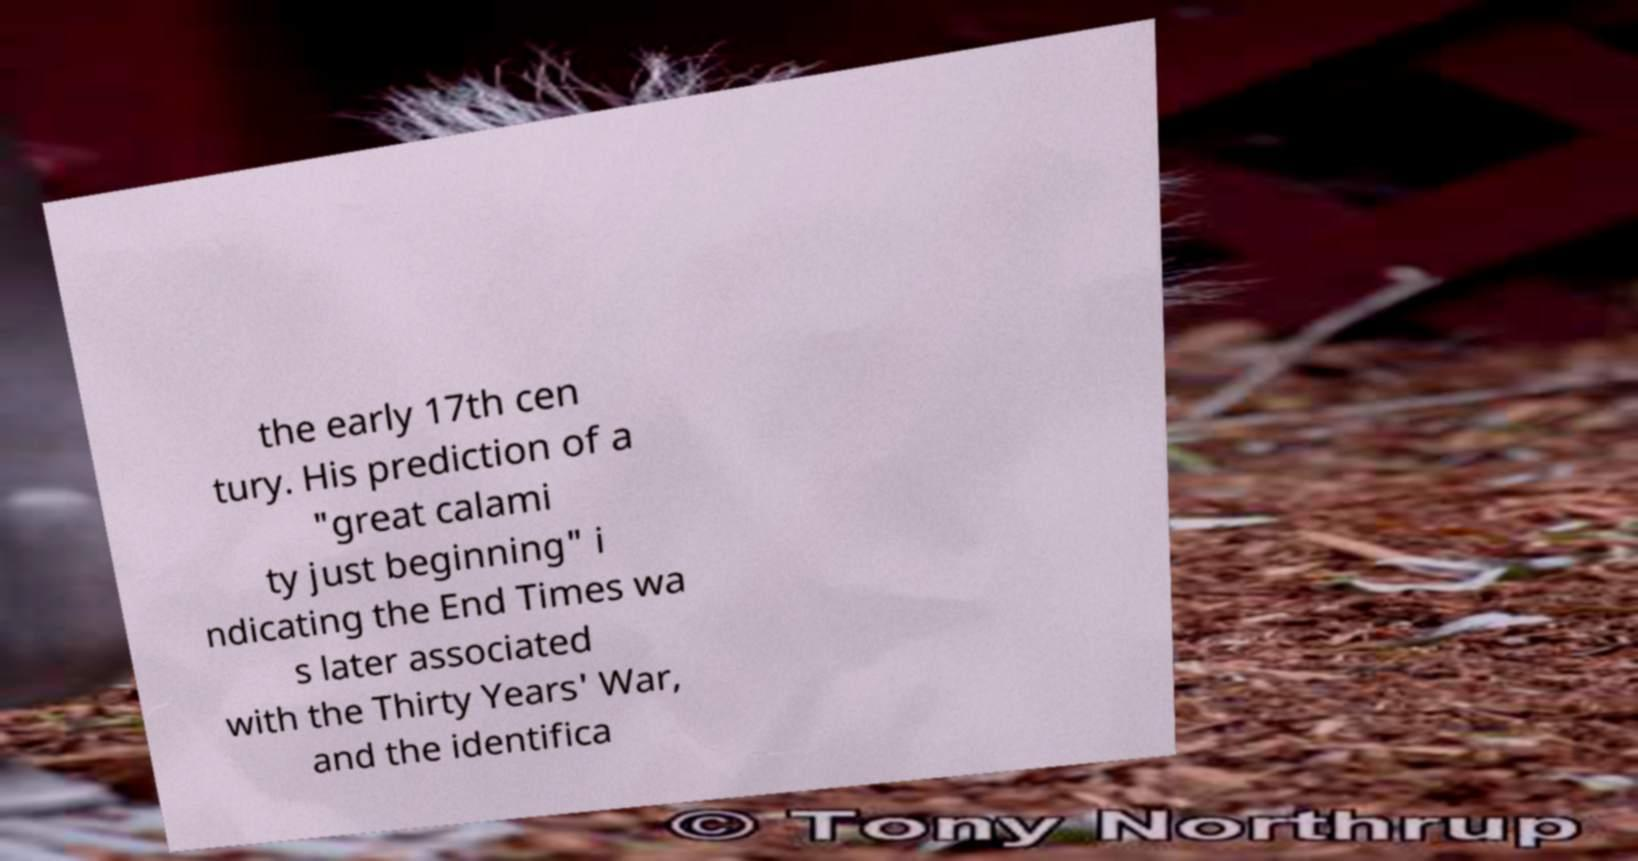What messages or text are displayed in this image? I need them in a readable, typed format. the early 17th cen tury. His prediction of a "great calami ty just beginning" i ndicating the End Times wa s later associated with the Thirty Years' War, and the identifica 